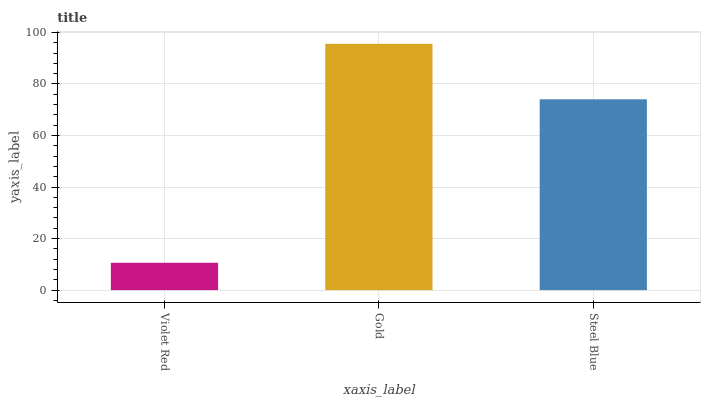Is Violet Red the minimum?
Answer yes or no. Yes. Is Gold the maximum?
Answer yes or no. Yes. Is Steel Blue the minimum?
Answer yes or no. No. Is Steel Blue the maximum?
Answer yes or no. No. Is Gold greater than Steel Blue?
Answer yes or no. Yes. Is Steel Blue less than Gold?
Answer yes or no. Yes. Is Steel Blue greater than Gold?
Answer yes or no. No. Is Gold less than Steel Blue?
Answer yes or no. No. Is Steel Blue the high median?
Answer yes or no. Yes. Is Steel Blue the low median?
Answer yes or no. Yes. Is Gold the high median?
Answer yes or no. No. Is Gold the low median?
Answer yes or no. No. 